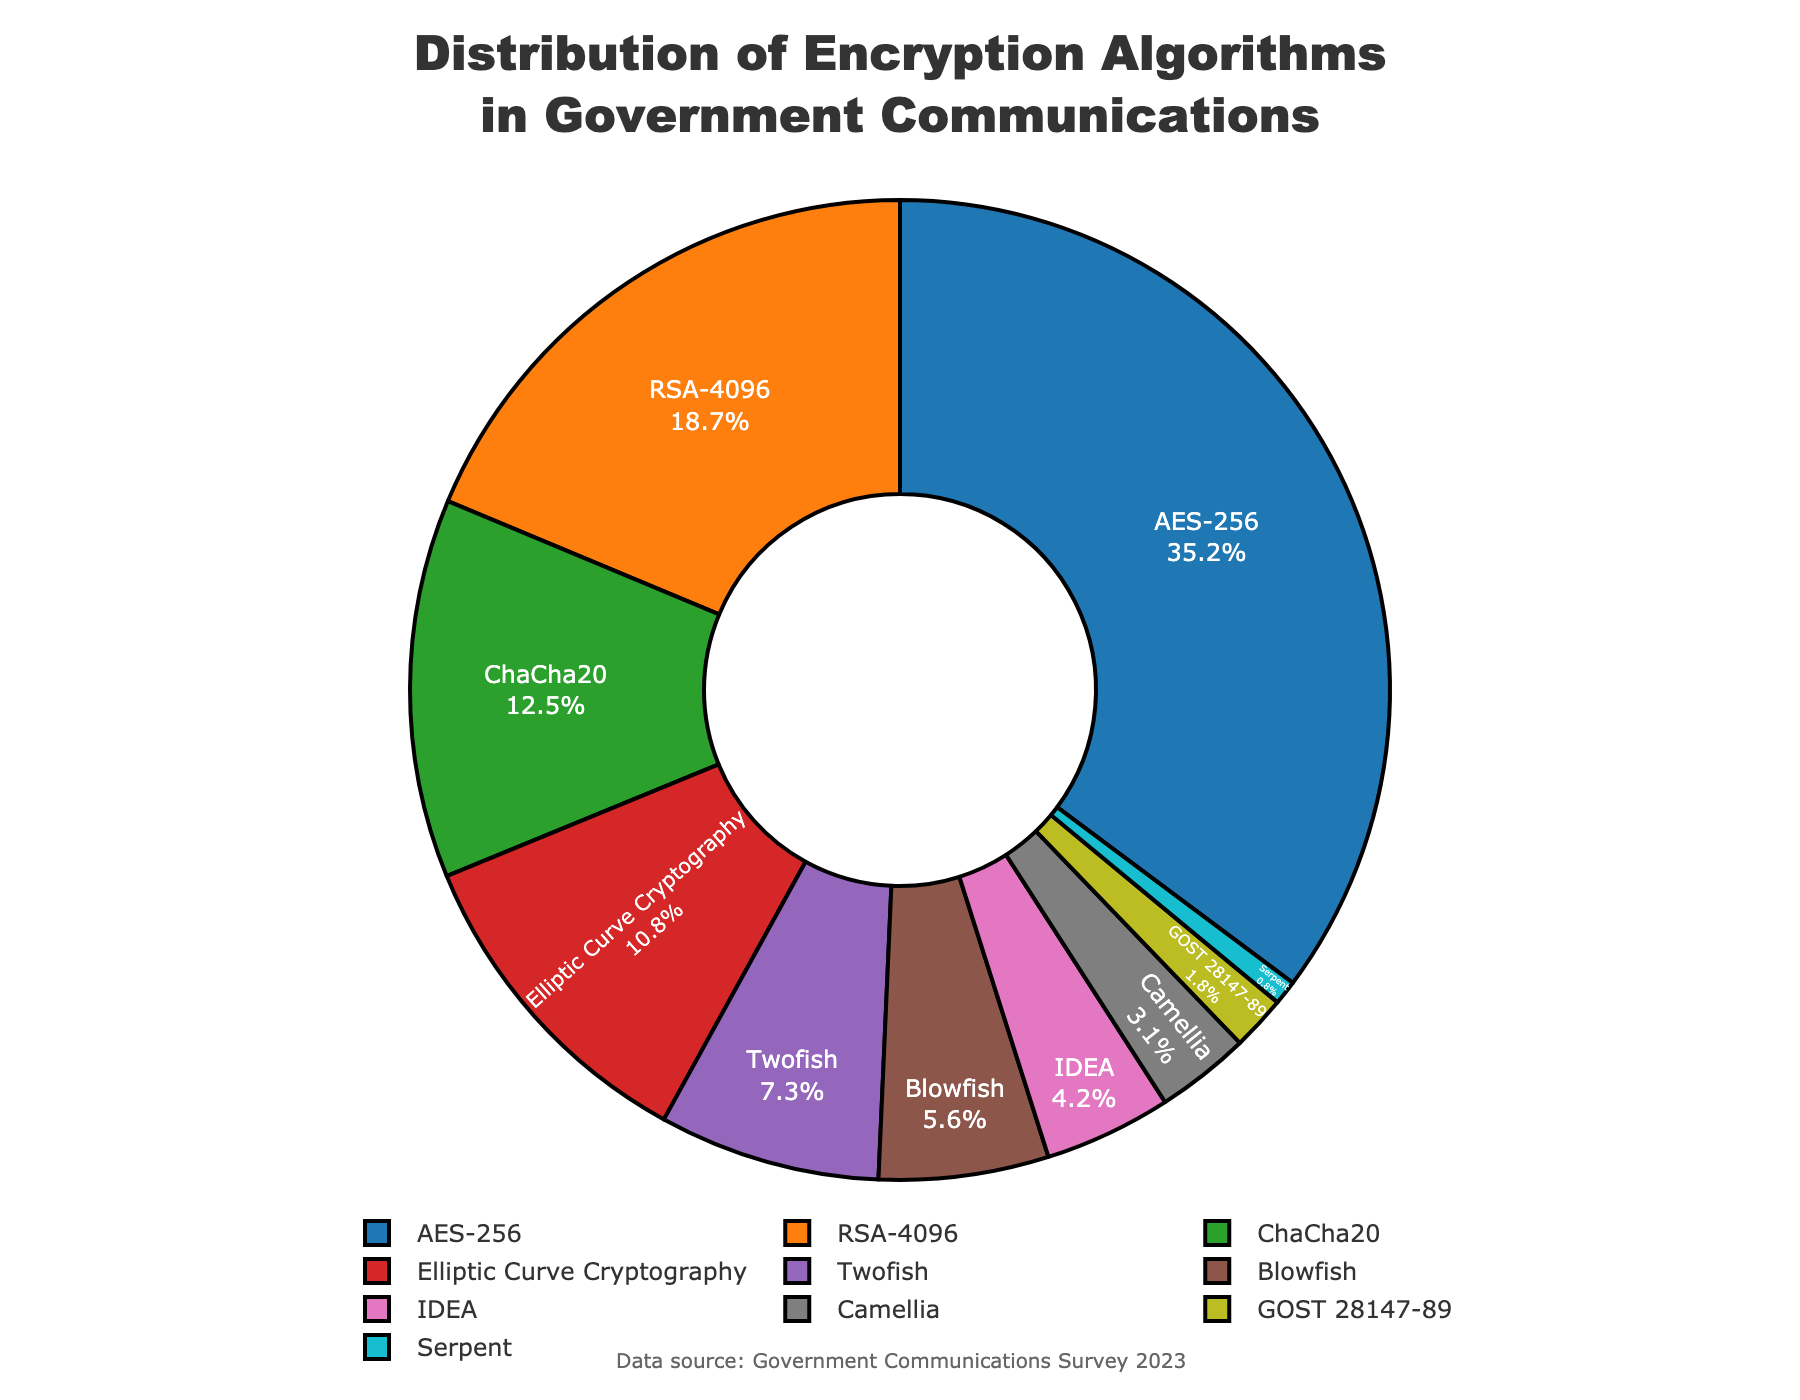Which encryption algorithm is used the most in government communications? The slice with the largest percentage represents the most-used algorithm. By checking the sizes, we can see that AES-256 has the largest slice.
Answer: AES-256 Which encryption algorithms collectively cover more than 50% of the usage? Adding the percentages of the largest slices one by one until the total exceeds 50%. AES-256 (35.2%) + RSA-4096 (18.7%) = 53.9%, thus, both.
Answer: AES-256 and RSA-4096 What is the difference in usage percentage between AES-256 and ChaCha20? Subtract the percentage of ChaCha20 from that of AES-256: 35.2% - 12.5% = 22.7%.
Answer: 22.7% Which algorithm has the smallest percentage of usage? The slice with the smallest percentage represents the least-used algorithm. By checking the sizes, we can see that Serpent has the smallest slice.
Answer: Serpent How much more is Twofish used compared to Camellia? Subtract the percentage of Camellia from that of Twofish: 7.3% - 3.1% = 4.2%.
Answer: 4.2% What cumulative percentage do Elliptic Curve Cryptography, Twofish, and Blowfish constitute? Adding the percentages of these three algorithms: 10.8% + 7.3% + 5.6% = 23.7%.
Answer: 23.7% Which algorithm has a usage percentage closest to RSA-4096? Comparing the percentages of other algorithms with that of RSA-4096 (18.7%), ChaCha20 (12.5%) is the closest.
Answer: ChaCha20 Rank the top three algorithms by usage percentage. From the figure, the top three slices are AES-256 (35.2%), RSA-4096 (18.7%), and ChaCha20 (12.5%).
Answer: 1. AES-256 2. RSA-4096 3. ChaCha20 What is the total percentage of symmetric-key algorithms in the chart? Summing the percentages of symmetric-key algorithms: AES-256 (35.2%) + ChaCha20 (12.5%) + Twofish (7.3%) + Blowfish (5.6%) + IDEA (4.2%) + Camellia (3.1%) + GOST 28147-89 (1.8%) + Serpent (0.8%) = 70.5%.
Answer: 70.5% 